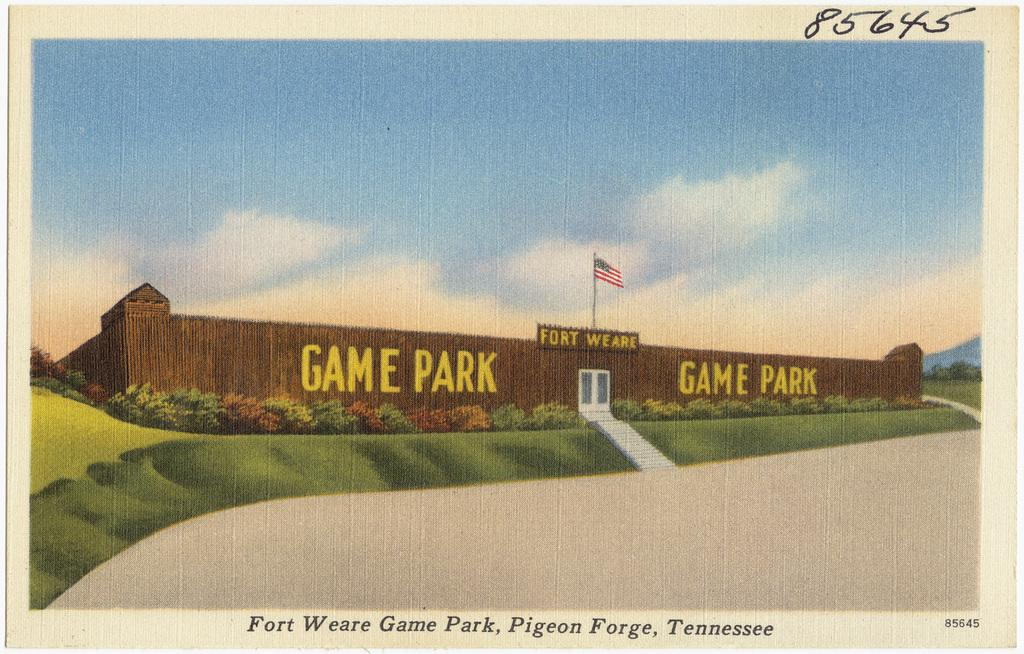<image>
Summarize the visual content of the image. An outside of a brick wall that has Game Park written on the front of the bricks and an American flag flying above in the background. 